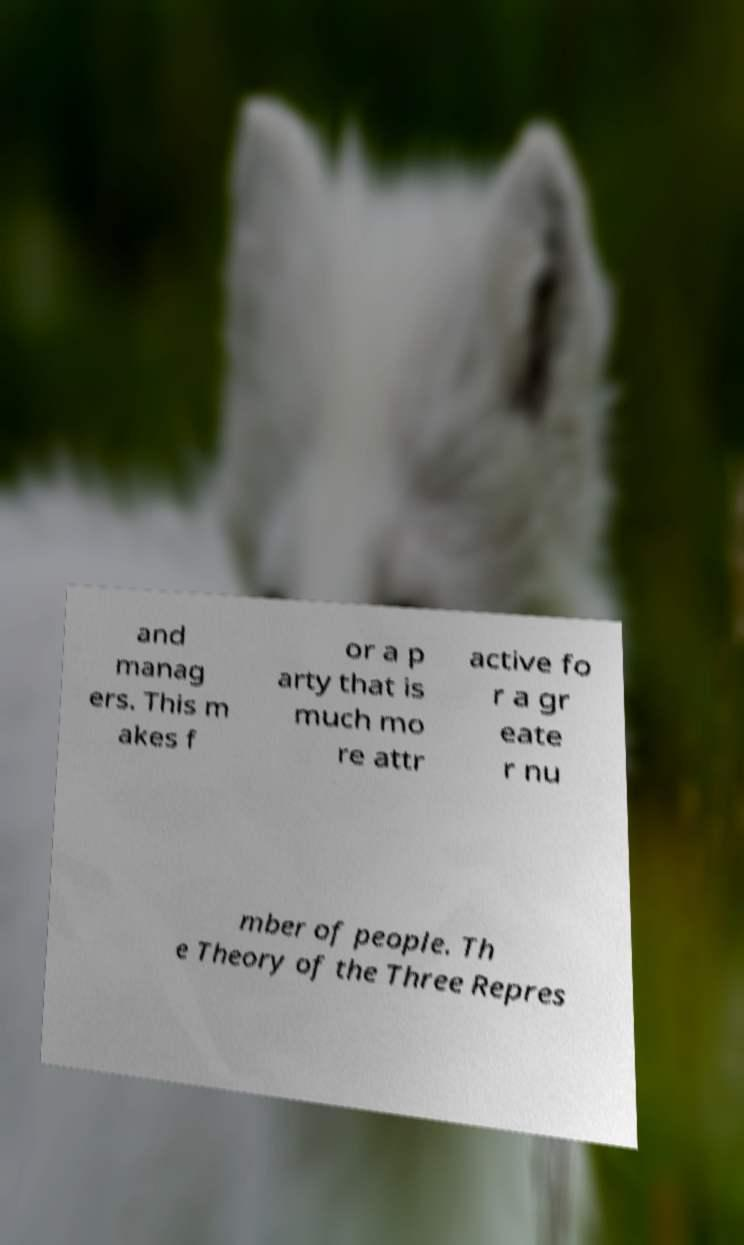For documentation purposes, I need the text within this image transcribed. Could you provide that? and manag ers. This m akes f or a p arty that is much mo re attr active fo r a gr eate r nu mber of people. Th e Theory of the Three Repres 